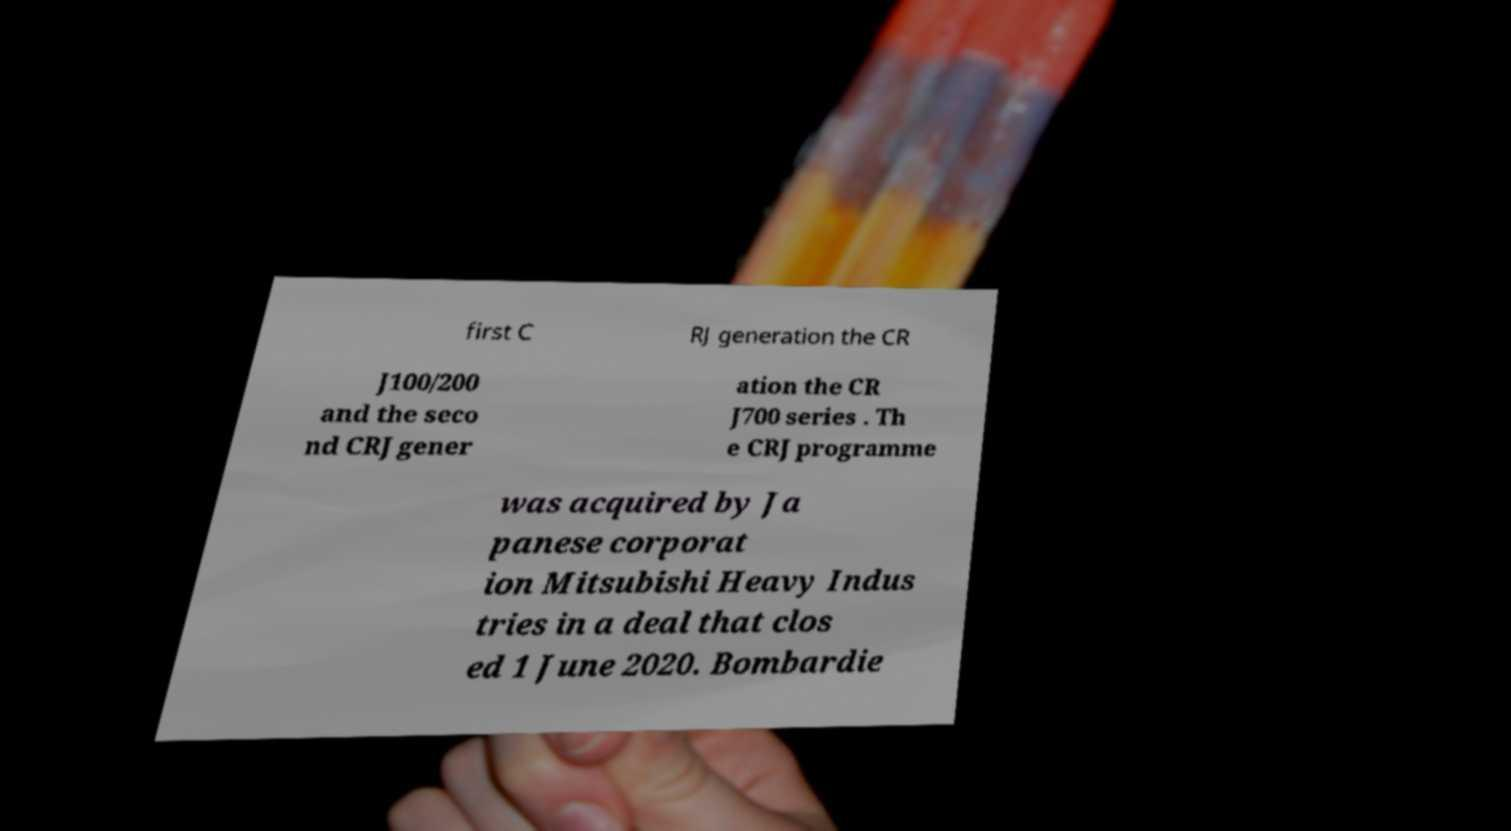What messages or text are displayed in this image? I need them in a readable, typed format. first C RJ generation the CR J100/200 and the seco nd CRJ gener ation the CR J700 series . Th e CRJ programme was acquired by Ja panese corporat ion Mitsubishi Heavy Indus tries in a deal that clos ed 1 June 2020. Bombardie 